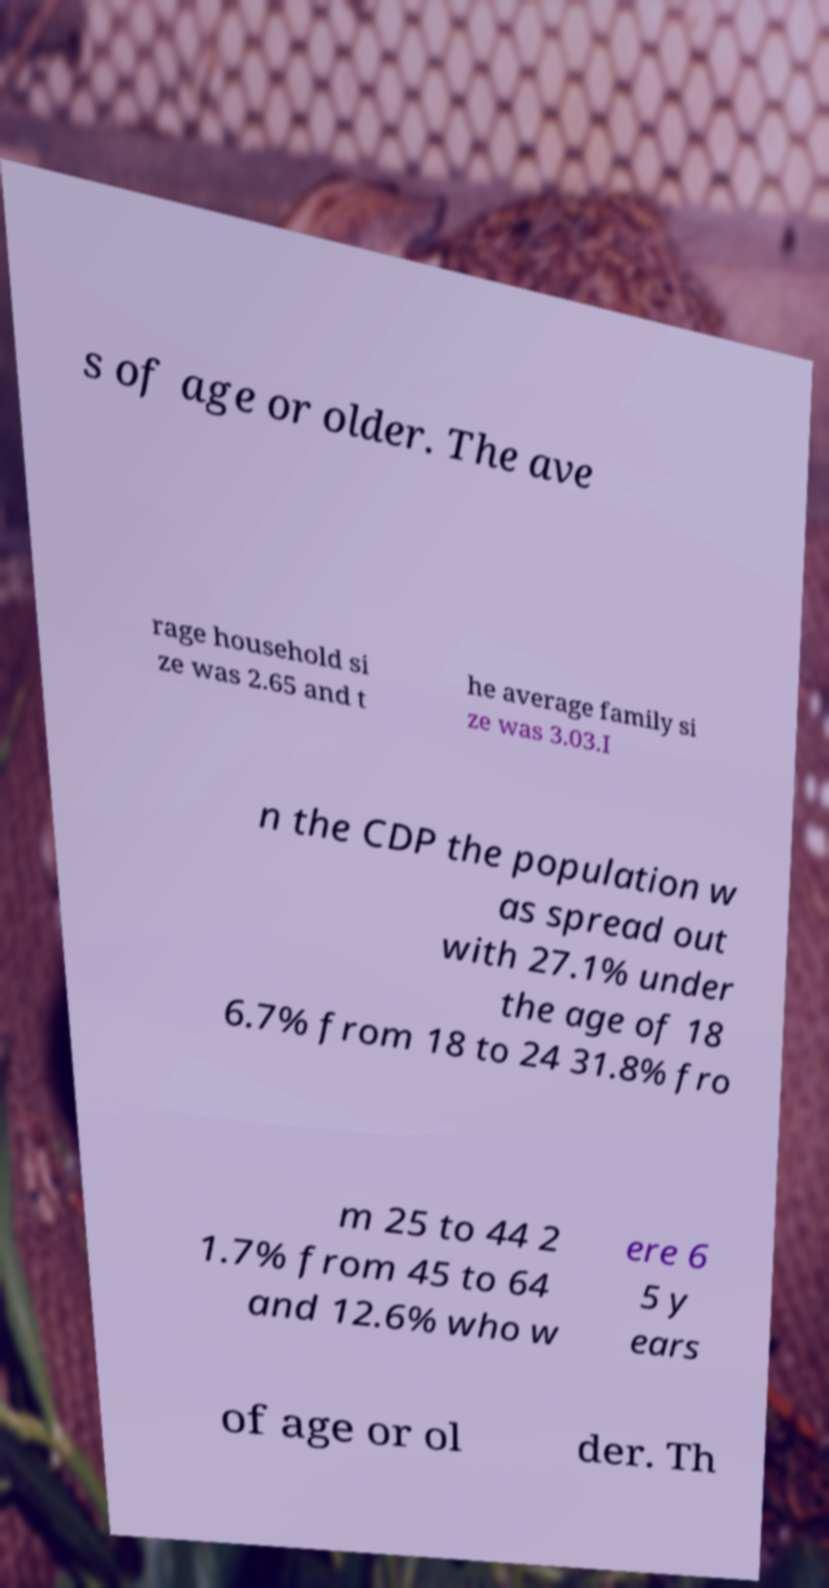Can you accurately transcribe the text from the provided image for me? s of age or older. The ave rage household si ze was 2.65 and t he average family si ze was 3.03.I n the CDP the population w as spread out with 27.1% under the age of 18 6.7% from 18 to 24 31.8% fro m 25 to 44 2 1.7% from 45 to 64 and 12.6% who w ere 6 5 y ears of age or ol der. Th 